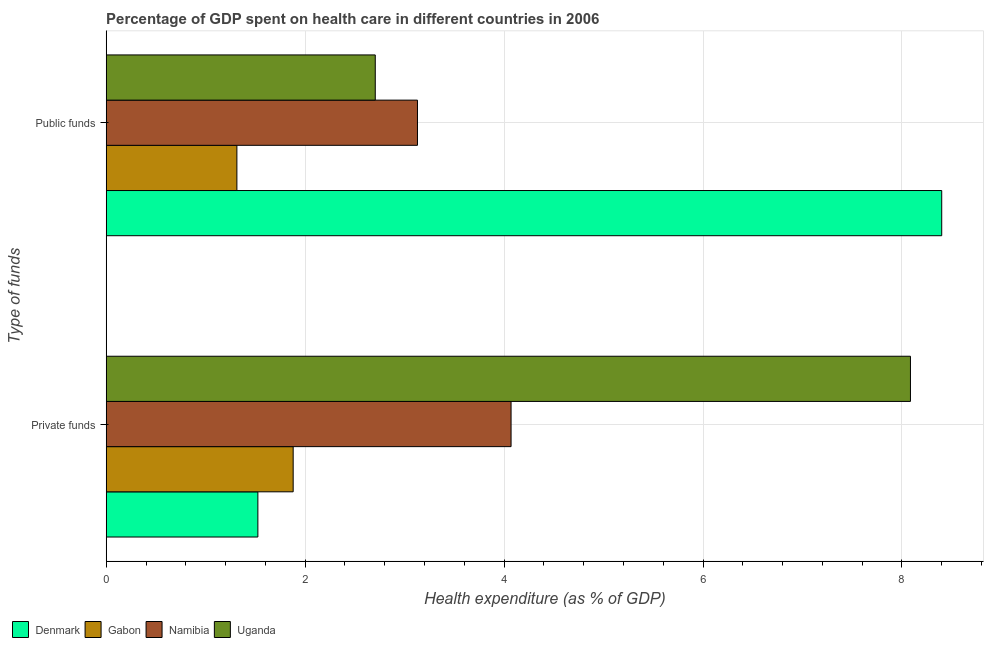How many groups of bars are there?
Provide a short and direct response. 2. How many bars are there on the 2nd tick from the bottom?
Keep it short and to the point. 4. What is the label of the 1st group of bars from the top?
Provide a short and direct response. Public funds. What is the amount of public funds spent in healthcare in Namibia?
Give a very brief answer. 3.13. Across all countries, what is the maximum amount of private funds spent in healthcare?
Your answer should be very brief. 8.09. Across all countries, what is the minimum amount of private funds spent in healthcare?
Keep it short and to the point. 1.52. In which country was the amount of private funds spent in healthcare maximum?
Your response must be concise. Uganda. In which country was the amount of private funds spent in healthcare minimum?
Provide a short and direct response. Denmark. What is the total amount of private funds spent in healthcare in the graph?
Offer a terse response. 15.56. What is the difference between the amount of private funds spent in healthcare in Uganda and that in Denmark?
Your answer should be compact. 6.56. What is the difference between the amount of private funds spent in healthcare in Namibia and the amount of public funds spent in healthcare in Gabon?
Offer a terse response. 2.76. What is the average amount of public funds spent in healthcare per country?
Your answer should be very brief. 3.89. What is the difference between the amount of public funds spent in healthcare and amount of private funds spent in healthcare in Uganda?
Ensure brevity in your answer.  -5.38. In how many countries, is the amount of private funds spent in healthcare greater than 4 %?
Your answer should be very brief. 2. What is the ratio of the amount of public funds spent in healthcare in Gabon to that in Uganda?
Give a very brief answer. 0.49. In how many countries, is the amount of public funds spent in healthcare greater than the average amount of public funds spent in healthcare taken over all countries?
Your response must be concise. 1. What does the 2nd bar from the top in Private funds represents?
Give a very brief answer. Namibia. What does the 2nd bar from the bottom in Public funds represents?
Offer a very short reply. Gabon. How many bars are there?
Give a very brief answer. 8. How many countries are there in the graph?
Offer a very short reply. 4. What is the difference between two consecutive major ticks on the X-axis?
Your answer should be compact. 2. Are the values on the major ticks of X-axis written in scientific E-notation?
Provide a succinct answer. No. Does the graph contain grids?
Give a very brief answer. Yes. Where does the legend appear in the graph?
Offer a very short reply. Bottom left. How many legend labels are there?
Your answer should be very brief. 4. How are the legend labels stacked?
Offer a very short reply. Horizontal. What is the title of the graph?
Keep it short and to the point. Percentage of GDP spent on health care in different countries in 2006. What is the label or title of the X-axis?
Your answer should be compact. Health expenditure (as % of GDP). What is the label or title of the Y-axis?
Your response must be concise. Type of funds. What is the Health expenditure (as % of GDP) in Denmark in Private funds?
Ensure brevity in your answer.  1.52. What is the Health expenditure (as % of GDP) in Gabon in Private funds?
Make the answer very short. 1.88. What is the Health expenditure (as % of GDP) in Namibia in Private funds?
Your answer should be very brief. 4.07. What is the Health expenditure (as % of GDP) in Uganda in Private funds?
Ensure brevity in your answer.  8.09. What is the Health expenditure (as % of GDP) in Denmark in Public funds?
Make the answer very short. 8.4. What is the Health expenditure (as % of GDP) of Gabon in Public funds?
Offer a terse response. 1.31. What is the Health expenditure (as % of GDP) in Namibia in Public funds?
Your answer should be very brief. 3.13. What is the Health expenditure (as % of GDP) in Uganda in Public funds?
Your answer should be compact. 2.7. Across all Type of funds, what is the maximum Health expenditure (as % of GDP) in Denmark?
Ensure brevity in your answer.  8.4. Across all Type of funds, what is the maximum Health expenditure (as % of GDP) in Gabon?
Your answer should be very brief. 1.88. Across all Type of funds, what is the maximum Health expenditure (as % of GDP) of Namibia?
Your answer should be compact. 4.07. Across all Type of funds, what is the maximum Health expenditure (as % of GDP) in Uganda?
Your answer should be very brief. 8.09. Across all Type of funds, what is the minimum Health expenditure (as % of GDP) in Denmark?
Your answer should be very brief. 1.52. Across all Type of funds, what is the minimum Health expenditure (as % of GDP) in Gabon?
Your answer should be compact. 1.31. Across all Type of funds, what is the minimum Health expenditure (as % of GDP) of Namibia?
Make the answer very short. 3.13. Across all Type of funds, what is the minimum Health expenditure (as % of GDP) in Uganda?
Keep it short and to the point. 2.7. What is the total Health expenditure (as % of GDP) in Denmark in the graph?
Keep it short and to the point. 9.92. What is the total Health expenditure (as % of GDP) in Gabon in the graph?
Make the answer very short. 3.19. What is the total Health expenditure (as % of GDP) of Namibia in the graph?
Provide a short and direct response. 7.2. What is the total Health expenditure (as % of GDP) in Uganda in the graph?
Your answer should be very brief. 10.79. What is the difference between the Health expenditure (as % of GDP) in Denmark in Private funds and that in Public funds?
Provide a short and direct response. -6.87. What is the difference between the Health expenditure (as % of GDP) in Gabon in Private funds and that in Public funds?
Your answer should be very brief. 0.57. What is the difference between the Health expenditure (as % of GDP) of Namibia in Private funds and that in Public funds?
Ensure brevity in your answer.  0.94. What is the difference between the Health expenditure (as % of GDP) of Uganda in Private funds and that in Public funds?
Ensure brevity in your answer.  5.38. What is the difference between the Health expenditure (as % of GDP) of Denmark in Private funds and the Health expenditure (as % of GDP) of Gabon in Public funds?
Provide a succinct answer. 0.21. What is the difference between the Health expenditure (as % of GDP) of Denmark in Private funds and the Health expenditure (as % of GDP) of Namibia in Public funds?
Ensure brevity in your answer.  -1.6. What is the difference between the Health expenditure (as % of GDP) of Denmark in Private funds and the Health expenditure (as % of GDP) of Uganda in Public funds?
Provide a succinct answer. -1.18. What is the difference between the Health expenditure (as % of GDP) of Gabon in Private funds and the Health expenditure (as % of GDP) of Namibia in Public funds?
Your answer should be compact. -1.25. What is the difference between the Health expenditure (as % of GDP) of Gabon in Private funds and the Health expenditure (as % of GDP) of Uganda in Public funds?
Give a very brief answer. -0.83. What is the difference between the Health expenditure (as % of GDP) of Namibia in Private funds and the Health expenditure (as % of GDP) of Uganda in Public funds?
Provide a short and direct response. 1.37. What is the average Health expenditure (as % of GDP) of Denmark per Type of funds?
Provide a succinct answer. 4.96. What is the average Health expenditure (as % of GDP) in Gabon per Type of funds?
Provide a succinct answer. 1.6. What is the average Health expenditure (as % of GDP) in Namibia per Type of funds?
Your answer should be very brief. 3.6. What is the average Health expenditure (as % of GDP) in Uganda per Type of funds?
Give a very brief answer. 5.4. What is the difference between the Health expenditure (as % of GDP) in Denmark and Health expenditure (as % of GDP) in Gabon in Private funds?
Give a very brief answer. -0.35. What is the difference between the Health expenditure (as % of GDP) in Denmark and Health expenditure (as % of GDP) in Namibia in Private funds?
Give a very brief answer. -2.55. What is the difference between the Health expenditure (as % of GDP) of Denmark and Health expenditure (as % of GDP) of Uganda in Private funds?
Offer a terse response. -6.56. What is the difference between the Health expenditure (as % of GDP) in Gabon and Health expenditure (as % of GDP) in Namibia in Private funds?
Your answer should be very brief. -2.19. What is the difference between the Health expenditure (as % of GDP) of Gabon and Health expenditure (as % of GDP) of Uganda in Private funds?
Your answer should be very brief. -6.21. What is the difference between the Health expenditure (as % of GDP) of Namibia and Health expenditure (as % of GDP) of Uganda in Private funds?
Ensure brevity in your answer.  -4.02. What is the difference between the Health expenditure (as % of GDP) of Denmark and Health expenditure (as % of GDP) of Gabon in Public funds?
Your response must be concise. 7.09. What is the difference between the Health expenditure (as % of GDP) in Denmark and Health expenditure (as % of GDP) in Namibia in Public funds?
Ensure brevity in your answer.  5.27. What is the difference between the Health expenditure (as % of GDP) in Denmark and Health expenditure (as % of GDP) in Uganda in Public funds?
Offer a terse response. 5.69. What is the difference between the Health expenditure (as % of GDP) of Gabon and Health expenditure (as % of GDP) of Namibia in Public funds?
Keep it short and to the point. -1.82. What is the difference between the Health expenditure (as % of GDP) in Gabon and Health expenditure (as % of GDP) in Uganda in Public funds?
Your answer should be compact. -1.39. What is the difference between the Health expenditure (as % of GDP) of Namibia and Health expenditure (as % of GDP) of Uganda in Public funds?
Make the answer very short. 0.42. What is the ratio of the Health expenditure (as % of GDP) in Denmark in Private funds to that in Public funds?
Offer a very short reply. 0.18. What is the ratio of the Health expenditure (as % of GDP) in Gabon in Private funds to that in Public funds?
Keep it short and to the point. 1.43. What is the ratio of the Health expenditure (as % of GDP) of Namibia in Private funds to that in Public funds?
Offer a terse response. 1.3. What is the ratio of the Health expenditure (as % of GDP) of Uganda in Private funds to that in Public funds?
Provide a succinct answer. 2.99. What is the difference between the highest and the second highest Health expenditure (as % of GDP) in Denmark?
Give a very brief answer. 6.87. What is the difference between the highest and the second highest Health expenditure (as % of GDP) of Gabon?
Provide a succinct answer. 0.57. What is the difference between the highest and the second highest Health expenditure (as % of GDP) in Namibia?
Your response must be concise. 0.94. What is the difference between the highest and the second highest Health expenditure (as % of GDP) in Uganda?
Make the answer very short. 5.38. What is the difference between the highest and the lowest Health expenditure (as % of GDP) in Denmark?
Offer a very short reply. 6.87. What is the difference between the highest and the lowest Health expenditure (as % of GDP) in Gabon?
Provide a short and direct response. 0.57. What is the difference between the highest and the lowest Health expenditure (as % of GDP) in Namibia?
Offer a very short reply. 0.94. What is the difference between the highest and the lowest Health expenditure (as % of GDP) of Uganda?
Your answer should be compact. 5.38. 